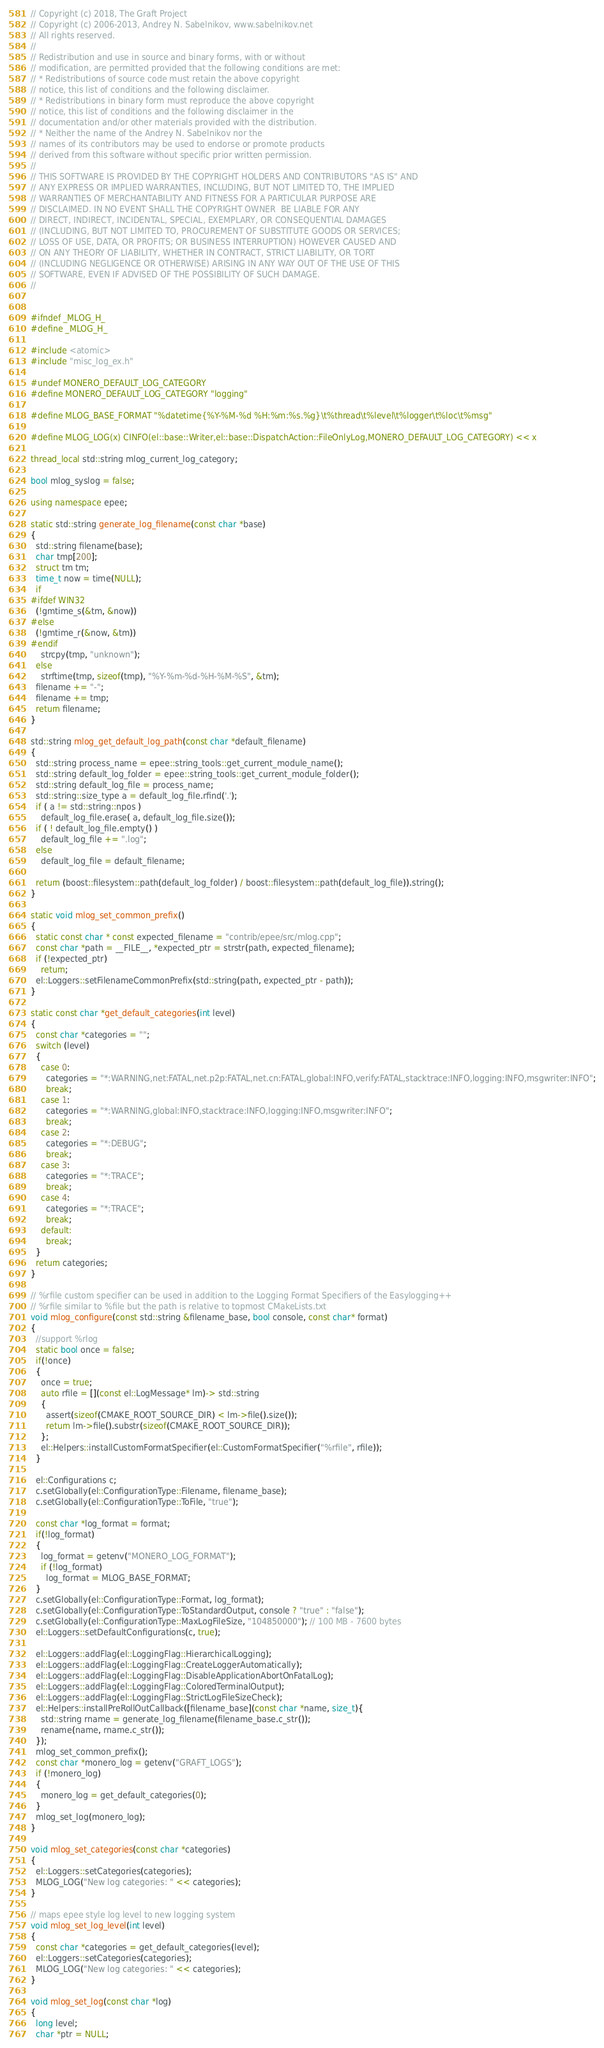<code> <loc_0><loc_0><loc_500><loc_500><_C++_>// Copyright (c) 2018, The Graft Project
// Copyright (c) 2006-2013, Andrey N. Sabelnikov, www.sabelnikov.net
// All rights reserved.
//
// Redistribution and use in source and binary forms, with or without
// modification, are permitted provided that the following conditions are met:
// * Redistributions of source code must retain the above copyright
// notice, this list of conditions and the following disclaimer.
// * Redistributions in binary form must reproduce the above copyright
// notice, this list of conditions and the following disclaimer in the
// documentation and/or other materials provided with the distribution.
// * Neither the name of the Andrey N. Sabelnikov nor the
// names of its contributors may be used to endorse or promote products
// derived from this software without specific prior written permission.
//
// THIS SOFTWARE IS PROVIDED BY THE COPYRIGHT HOLDERS AND CONTRIBUTORS "AS IS" AND
// ANY EXPRESS OR IMPLIED WARRANTIES, INCLUDING, BUT NOT LIMITED TO, THE IMPLIED
// WARRANTIES OF MERCHANTABILITY AND FITNESS FOR A PARTICULAR PURPOSE ARE
// DISCLAIMED. IN NO EVENT SHALL THE COPYRIGHT OWNER  BE LIABLE FOR ANY
// DIRECT, INDIRECT, INCIDENTAL, SPECIAL, EXEMPLARY, OR CONSEQUENTIAL DAMAGES
// (INCLUDING, BUT NOT LIMITED TO, PROCUREMENT OF SUBSTITUTE GOODS OR SERVICES;
// LOSS OF USE, DATA, OR PROFITS; OR BUSINESS INTERRUPTION) HOWEVER CAUSED AND
// ON ANY THEORY OF LIABILITY, WHETHER IN CONTRACT, STRICT LIABILITY, OR TORT
// (INCLUDING NEGLIGENCE OR OTHERWISE) ARISING IN ANY WAY OUT OF THE USE OF THIS
// SOFTWARE, EVEN IF ADVISED OF THE POSSIBILITY OF SUCH DAMAGE.
//


#ifndef _MLOG_H_
#define _MLOG_H_

#include <atomic>
#include "misc_log_ex.h"

#undef MONERO_DEFAULT_LOG_CATEGORY
#define MONERO_DEFAULT_LOG_CATEGORY "logging"

#define MLOG_BASE_FORMAT "%datetime{%Y-%M-%d %H:%m:%s.%g}\t%thread\t%level\t%logger\t%loc\t%msg"

#define MLOG_LOG(x) CINFO(el::base::Writer,el::base::DispatchAction::FileOnlyLog,MONERO_DEFAULT_LOG_CATEGORY) << x

thread_local std::string mlog_current_log_category;

bool mlog_syslog = false;

using namespace epee;

static std::string generate_log_filename(const char *base)
{
  std::string filename(base);
  char tmp[200];
  struct tm tm;
  time_t now = time(NULL);
  if
#ifdef WIN32
  (!gmtime_s(&tm, &now))
#else
  (!gmtime_r(&now, &tm))
#endif
    strcpy(tmp, "unknown");
  else
    strftime(tmp, sizeof(tmp), "%Y-%m-%d-%H-%M-%S", &tm);
  filename += "-";
  filename += tmp;
  return filename;
}

std::string mlog_get_default_log_path(const char *default_filename)
{
  std::string process_name = epee::string_tools::get_current_module_name();
  std::string default_log_folder = epee::string_tools::get_current_module_folder();
  std::string default_log_file = process_name;
  std::string::size_type a = default_log_file.rfind('.');
  if ( a != std::string::npos )
    default_log_file.erase( a, default_log_file.size());
  if ( ! default_log_file.empty() )
    default_log_file += ".log";
  else
    default_log_file = default_filename;

  return (boost::filesystem::path(default_log_folder) / boost::filesystem::path(default_log_file)).string();
}

static void mlog_set_common_prefix()
{
  static const char * const expected_filename = "contrib/epee/src/mlog.cpp";
  const char *path = __FILE__, *expected_ptr = strstr(path, expected_filename);
  if (!expected_ptr)
    return;
  el::Loggers::setFilenameCommonPrefix(std::string(path, expected_ptr - path));
}

static const char *get_default_categories(int level)
{
  const char *categories = "";
  switch (level)
  {
    case 0:
      categories = "*:WARNING,net:FATAL,net.p2p:FATAL,net.cn:FATAL,global:INFO,verify:FATAL,stacktrace:INFO,logging:INFO,msgwriter:INFO";
      break;
    case 1:
      categories = "*:WARNING,global:INFO,stacktrace:INFO,logging:INFO,msgwriter:INFO";
      break;
    case 2:
      categories = "*:DEBUG";
      break;
    case 3:
      categories = "*:TRACE";
      break;
    case 4:
      categories = "*:TRACE";
      break;
    default:
      break;
  }
  return categories;
}

// %rfile custom specifier can be used in addition to the Logging Format Specifiers of the Easylogging++
// %rfile similar to %file but the path is relative to topmost CMakeLists.txt
void mlog_configure(const std::string &filename_base, bool console, const char* format)
{
  //support %rlog
  static bool once = false;
  if(!once)
  {
    once = true;
    auto rfile = [](const el::LogMessage* lm)-> std::string
    {
      assert(sizeof(CMAKE_ROOT_SOURCE_DIR) < lm->file().size());
      return lm->file().substr(sizeof(CMAKE_ROOT_SOURCE_DIR));
    };
    el::Helpers::installCustomFormatSpecifier(el::CustomFormatSpecifier("%rfile", rfile));
  }

  el::Configurations c;
  c.setGlobally(el::ConfigurationType::Filename, filename_base);
  c.setGlobally(el::ConfigurationType::ToFile, "true");

  const char *log_format = format;
  if(!log_format)
  {
    log_format = getenv("MONERO_LOG_FORMAT");
    if (!log_format)
      log_format = MLOG_BASE_FORMAT;
  }
  c.setGlobally(el::ConfigurationType::Format, log_format);
  c.setGlobally(el::ConfigurationType::ToStandardOutput, console ? "true" : "false");
  c.setGlobally(el::ConfigurationType::MaxLogFileSize, "104850000"); // 100 MB - 7600 bytes
  el::Loggers::setDefaultConfigurations(c, true);

  el::Loggers::addFlag(el::LoggingFlag::HierarchicalLogging);
  el::Loggers::addFlag(el::LoggingFlag::CreateLoggerAutomatically);
  el::Loggers::addFlag(el::LoggingFlag::DisableApplicationAbortOnFatalLog);
  el::Loggers::addFlag(el::LoggingFlag::ColoredTerminalOutput);
  el::Loggers::addFlag(el::LoggingFlag::StrictLogFileSizeCheck);
  el::Helpers::installPreRollOutCallback([filename_base](const char *name, size_t){
    std::string rname = generate_log_filename(filename_base.c_str());
    rename(name, rname.c_str());
  });
  mlog_set_common_prefix();
  const char *monero_log = getenv("GRAFT_LOGS");
  if (!monero_log)
  {
    monero_log = get_default_categories(0);
  }
  mlog_set_log(monero_log);
}

void mlog_set_categories(const char *categories)
{
  el::Loggers::setCategories(categories);
  MLOG_LOG("New log categories: " << categories);
}

// maps epee style log level to new logging system
void mlog_set_log_level(int level)
{
  const char *categories = get_default_categories(level);
  el::Loggers::setCategories(categories);
  MLOG_LOG("New log categories: " << categories);
}

void mlog_set_log(const char *log)
{
  long level;
  char *ptr = NULL;
</code> 